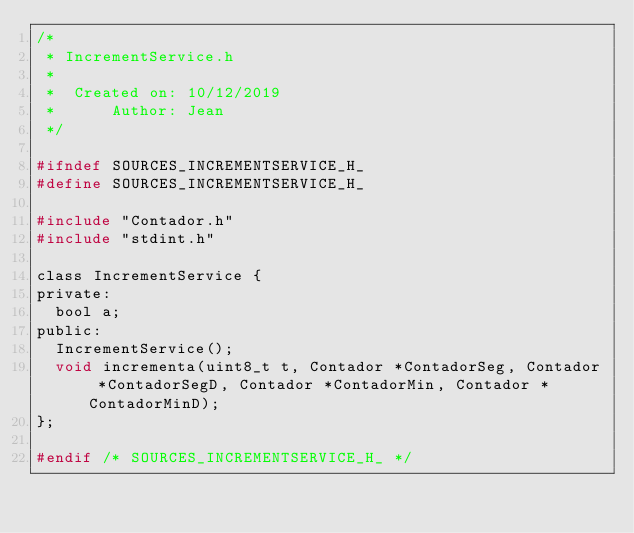<code> <loc_0><loc_0><loc_500><loc_500><_C_>/*
 * IncrementService.h
 *
 *  Created on: 10/12/2019
 *      Author: Jean
 */

#ifndef SOURCES_INCREMENTSERVICE_H_
#define SOURCES_INCREMENTSERVICE_H_

#include "Contador.h"
#include "stdint.h"

class IncrementService {
private:
	bool a;
public:
	IncrementService();
	void incrementa(uint8_t t, Contador *ContadorSeg, Contador *ContadorSegD, Contador *ContadorMin, Contador *ContadorMinD);
};

#endif /* SOURCES_INCREMENTSERVICE_H_ */
</code> 